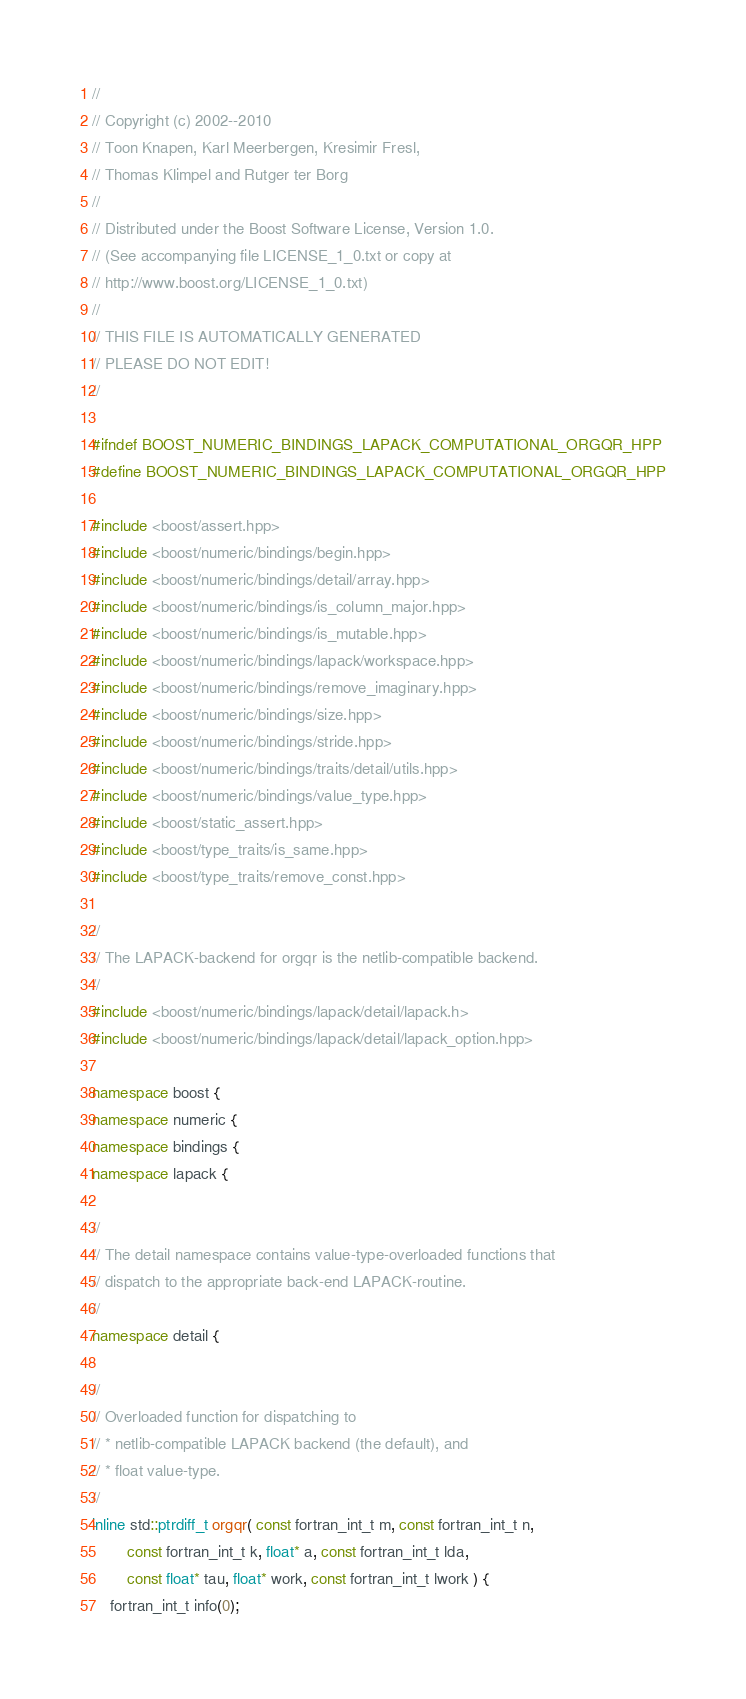<code> <loc_0><loc_0><loc_500><loc_500><_C++_>//
// Copyright (c) 2002--2010
// Toon Knapen, Karl Meerbergen, Kresimir Fresl,
// Thomas Klimpel and Rutger ter Borg
//
// Distributed under the Boost Software License, Version 1.0.
// (See accompanying file LICENSE_1_0.txt or copy at
// http://www.boost.org/LICENSE_1_0.txt)
//
// THIS FILE IS AUTOMATICALLY GENERATED
// PLEASE DO NOT EDIT!
//

#ifndef BOOST_NUMERIC_BINDINGS_LAPACK_COMPUTATIONAL_ORGQR_HPP
#define BOOST_NUMERIC_BINDINGS_LAPACK_COMPUTATIONAL_ORGQR_HPP

#include <boost/assert.hpp>
#include <boost/numeric/bindings/begin.hpp>
#include <boost/numeric/bindings/detail/array.hpp>
#include <boost/numeric/bindings/is_column_major.hpp>
#include <boost/numeric/bindings/is_mutable.hpp>
#include <boost/numeric/bindings/lapack/workspace.hpp>
#include <boost/numeric/bindings/remove_imaginary.hpp>
#include <boost/numeric/bindings/size.hpp>
#include <boost/numeric/bindings/stride.hpp>
#include <boost/numeric/bindings/traits/detail/utils.hpp>
#include <boost/numeric/bindings/value_type.hpp>
#include <boost/static_assert.hpp>
#include <boost/type_traits/is_same.hpp>
#include <boost/type_traits/remove_const.hpp>

//
// The LAPACK-backend for orgqr is the netlib-compatible backend.
//
#include <boost/numeric/bindings/lapack/detail/lapack.h>
#include <boost/numeric/bindings/lapack/detail/lapack_option.hpp>

namespace boost {
namespace numeric {
namespace bindings {
namespace lapack {

//
// The detail namespace contains value-type-overloaded functions that
// dispatch to the appropriate back-end LAPACK-routine.
//
namespace detail {

//
// Overloaded function for dispatching to
// * netlib-compatible LAPACK backend (the default), and
// * float value-type.
//
inline std::ptrdiff_t orgqr( const fortran_int_t m, const fortran_int_t n,
        const fortran_int_t k, float* a, const fortran_int_t lda,
        const float* tau, float* work, const fortran_int_t lwork ) {
    fortran_int_t info(0);</code> 